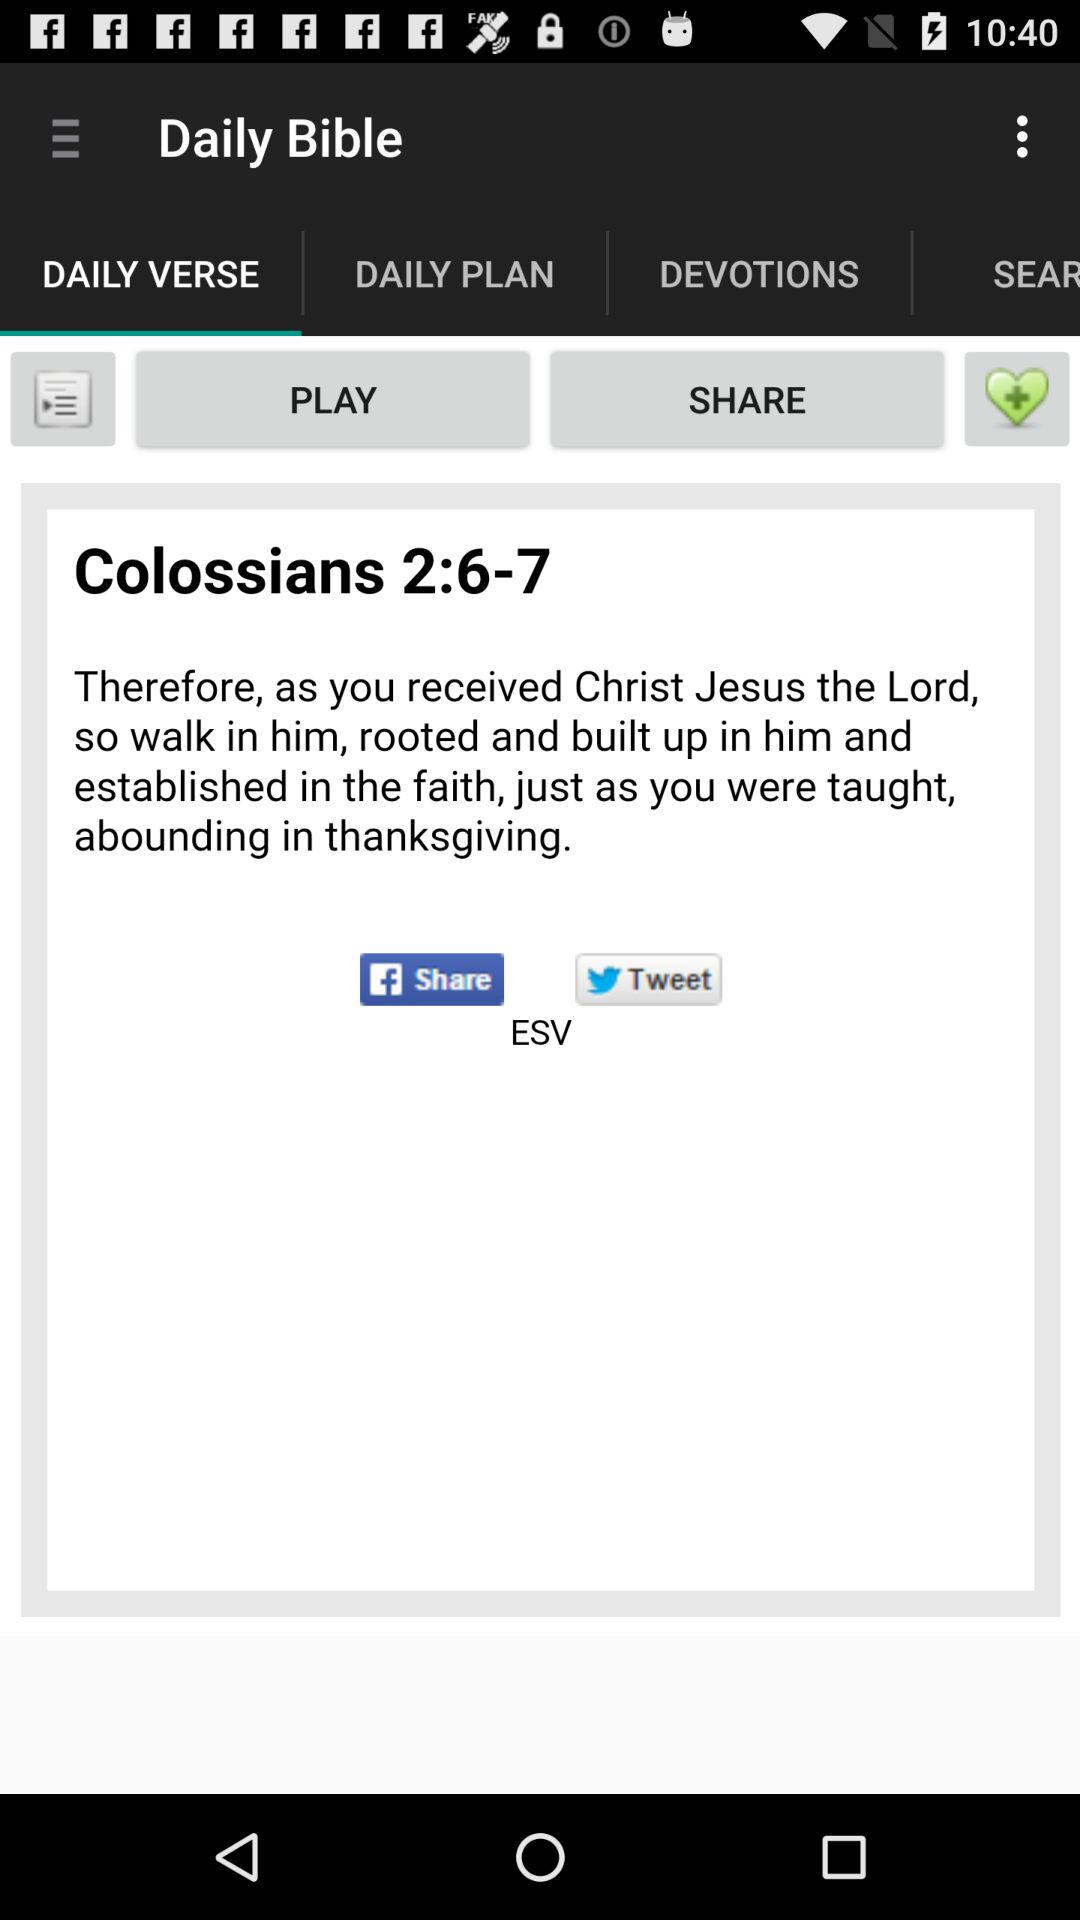Which are the different sharing options? The different sharing options are "Facebook" and "Twitter". 